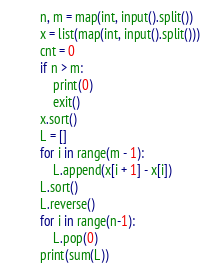<code> <loc_0><loc_0><loc_500><loc_500><_Python_>n, m = map(int, input().split())
x = list(map(int, input().split()))
cnt = 0
if n > m:
    print(0)
    exit()
x.sort()
L = []
for i in range(m - 1):
    L.append(x[i + 1] - x[i])
L.sort()
L.reverse()
for i in range(n-1):
    L.pop(0)
print(sum(L))
</code> 